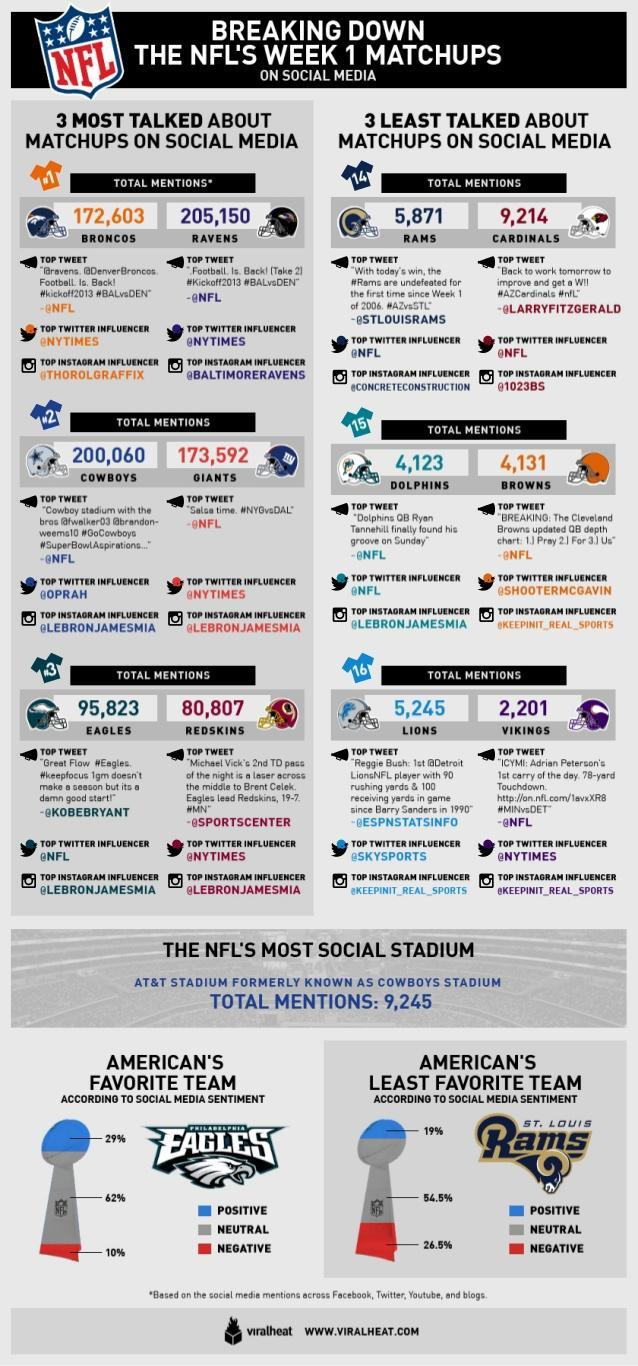What is rate of negative social medial sentiment received by team Rams?
Answer the question with a short phrase. 26.5% What is rate of neutral social medial sentiment received by team Eagles? 62% Which team has been matched up with Detroit Lions, Redskins, Minnesota Vikings, or Philadelphia Eagles? Minnesota Vikings Which team has the most mentions on social media? Ravens Which NFL team had the highest number of mentions on social media, Broncos, Ravens, Rams, or Cardinals ? Broncos What is the lowest count of mentions on social media? 2,201 